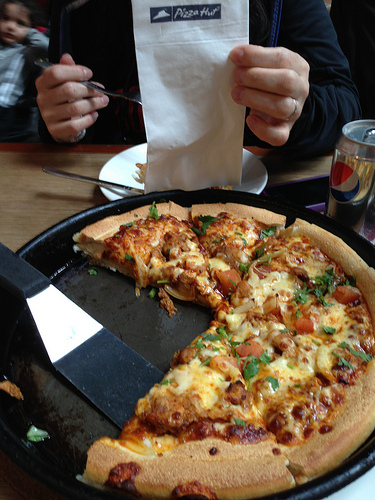Can you identify any instances of branding in the image? Yes, the image contains two noticeable instances of branding: the Pizza Hut logo on the napkin and the Pepsi logo on the can. What is the person in the image doing? The person in the image is holding a napkin with the Pizza Hut logo, and is possibly about to bring the fork near the pizza slice. It seems like they are about to enjoy their meal. Provide a very detailed narrative that might describe the scene in this image. The table is set in what looks like a casual dining setting. The main focus is a hot, freshly baked veggie pizza in a black round tray, its aroma almost wafting off the screen. The pizza has a thick, golden crust and is generously topped with colorful vegetables like tomatoes, onions, and green peppers, all held together with melting cheese. In the background, a person is about to take a bite, holding a fork in one hand and a napkin with the Pizza Hut logo in the other, possibly to catch any stray cheese or toppings. To the right, there's a can of Pepsi, its branding popping against the otherwise warm tones of the image. Behind them, a child looks curiously at the camera, capturing a candid moment in what appears to be a shared meal, full of anticipation and hunger. If you were at this table, what would you be looking forward to the most? If I were at this table, I would be looking forward to the first bite of that delicious-looking pizza, savoring its combination of fresh toppings and melting cheese. I might also enjoy a refreshing sip of the cold Pepsi to complement the flavors of the meal. Write a short story inspired by this image. It was a rainy Saturday afternoon, and the family had gathered at their favorite pizza parlor, Pizza Hut. The aroma of freshly baked pizza filled the air, mingling with the warm, comforting sounds of laughter and conversation. Little Timmy, fascinated by the camera, couldn't help but stare wide-eyed and curious. Dad held up a napkin, ready to dig into his slice, while a Pepsi waited nearby, ready to quench their thirst. They were all together, enjoying the little moments that often go unnoticed but create the strongest of bonds. This simple meal was a feast of love, laughter, and unspoken connections, making the rainy day feel warm and cozy. 